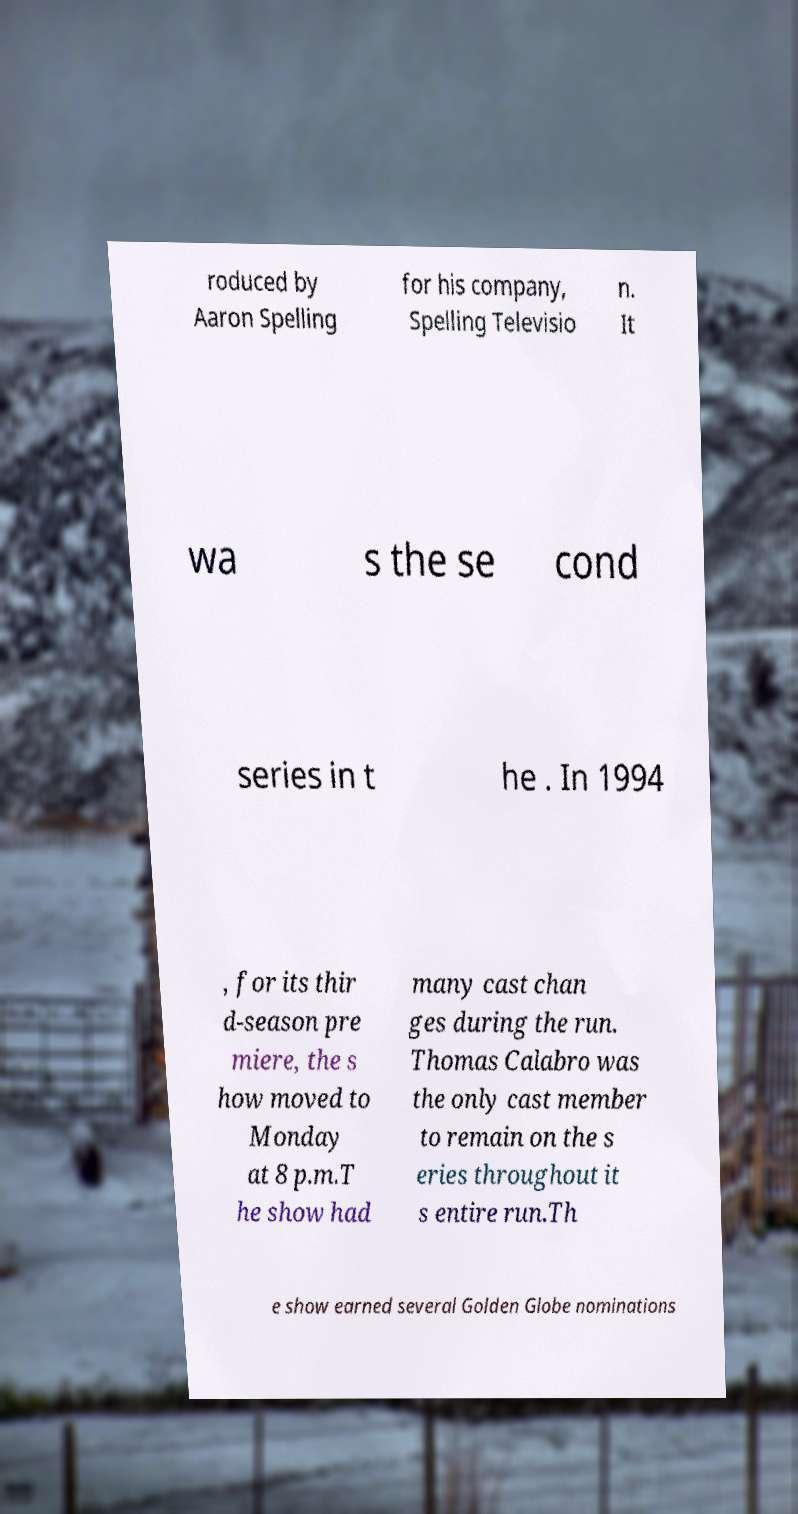Could you extract and type out the text from this image? roduced by Aaron Spelling for his company, Spelling Televisio n. It wa s the se cond series in t he . In 1994 , for its thir d-season pre miere, the s how moved to Monday at 8 p.m.T he show had many cast chan ges during the run. Thomas Calabro was the only cast member to remain on the s eries throughout it s entire run.Th e show earned several Golden Globe nominations 